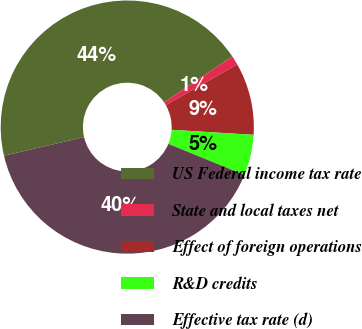<chart> <loc_0><loc_0><loc_500><loc_500><pie_chart><fcel>US Federal income tax rate<fcel>State and local taxes net<fcel>Effect of foreign operations<fcel>R&D credits<fcel>Effective tax rate (d)<nl><fcel>44.21%<fcel>1.18%<fcel>9.22%<fcel>5.2%<fcel>40.19%<nl></chart> 